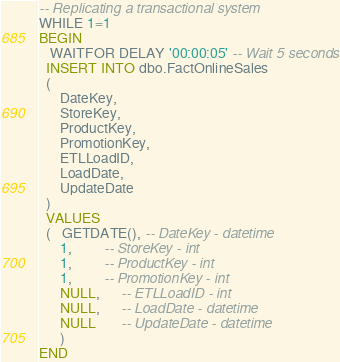Convert code to text. <code><loc_0><loc_0><loc_500><loc_500><_SQL_>
-- Replicating a transactional system
WHILE 1=1
BEGIN
   WAITFOR DELAY '00:00:05' -- Wait 5 seconds
  INSERT INTO dbo.FactOnlineSales
  (
      DateKey,
      StoreKey,
      ProductKey,
      PromotionKey,
      ETLLoadID,
      LoadDate,
      UpdateDate
  )
  VALUES
  (   GETDATE(), -- DateKey - datetime
      1,         -- StoreKey - int
      1,         -- ProductKey - int
      1,         -- PromotionKey - int
      NULL,      -- ETLLoadID - int
      NULL,      -- LoadDate - datetime
      NULL       -- UpdateDate - datetime
      )
END</code> 